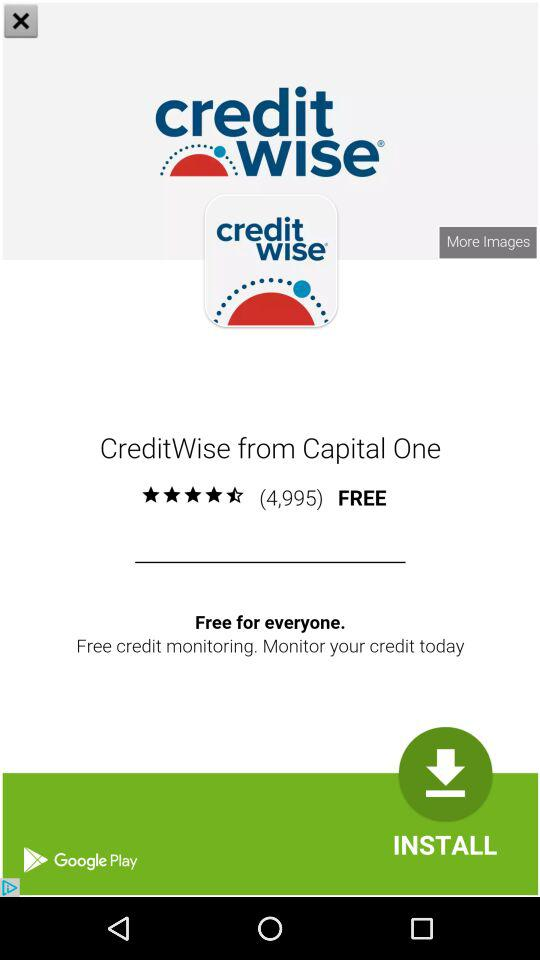How many more images are available?
When the provided information is insufficient, respond with <no answer>. <no answer> 